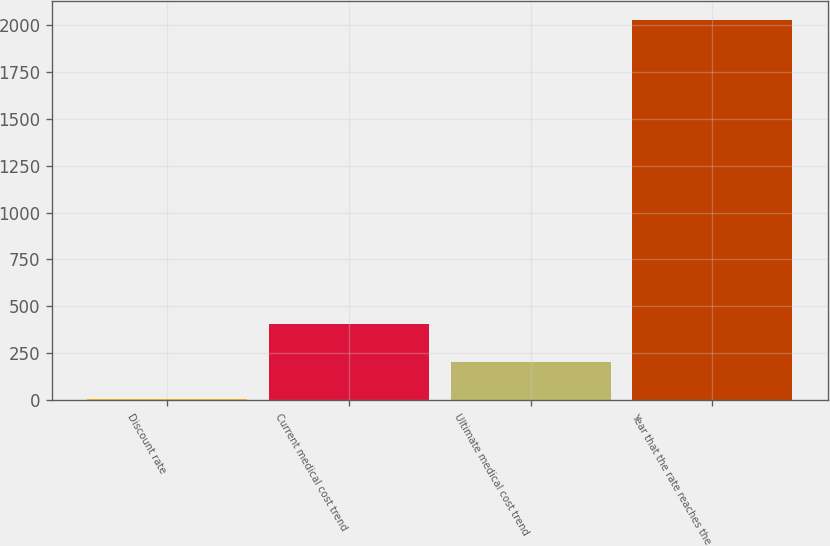Convert chart. <chart><loc_0><loc_0><loc_500><loc_500><bar_chart><fcel>Discount rate<fcel>Current medical cost trend<fcel>Ultimate medical cost trend<fcel>Year that the rate reaches the<nl><fcel>3.7<fcel>408.16<fcel>205.93<fcel>2026<nl></chart> 